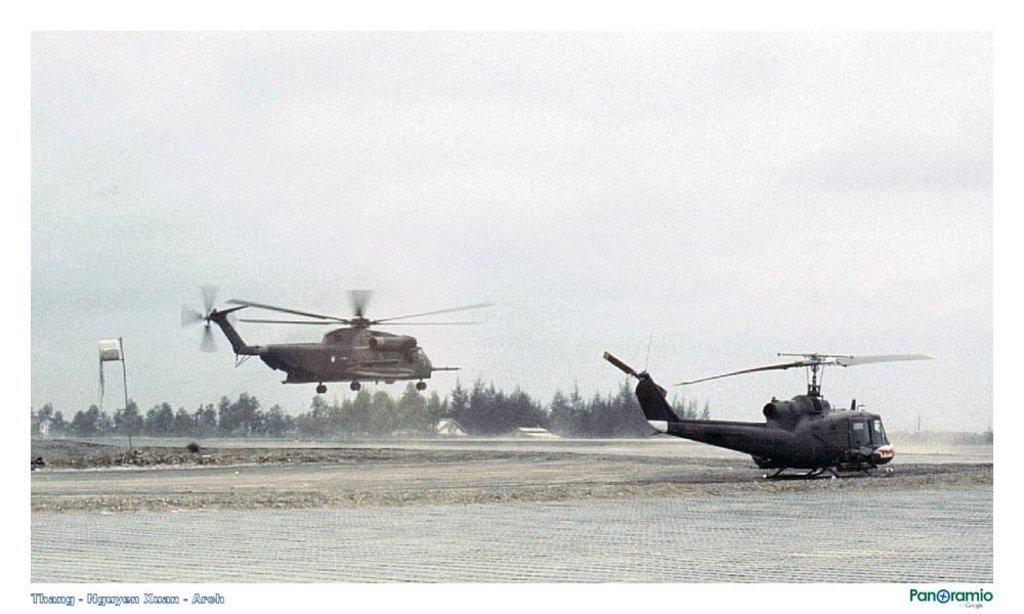In one or two sentences, can you explain what this image depicts? On the right side, we see a helicopter is on the runway. In the middle, we see a helicopter is flying in the sky. On the left side, we see the grass and a pole. We see a flag or a board in white color. There are trees in the background. At the bottom, we see the road. At the top, we see the sky. 